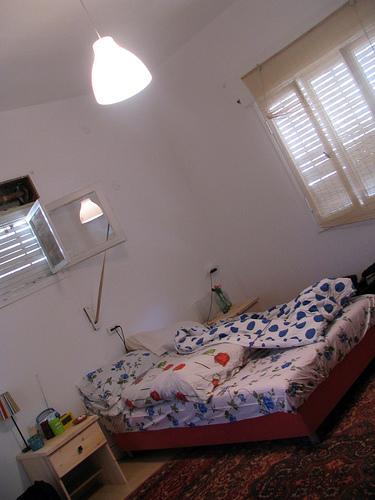What is the color of the walls?
Quick response, please. White. Who photographed the bedroom?
Quick response, please. Photographer. What room is this?
Short answer required. Bedroom. Is this bed made?
Answer briefly. No. 